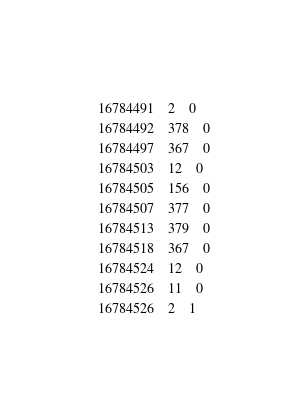<code> <loc_0><loc_0><loc_500><loc_500><_SQL_>16784491	2	0
16784492	378	0
16784497	367	0
16784503	12	0
16784505	156	0
16784507	377	0
16784513	379	0
16784518	367	0
16784524	12	0
16784526	11	0
16784526	2	1</code> 